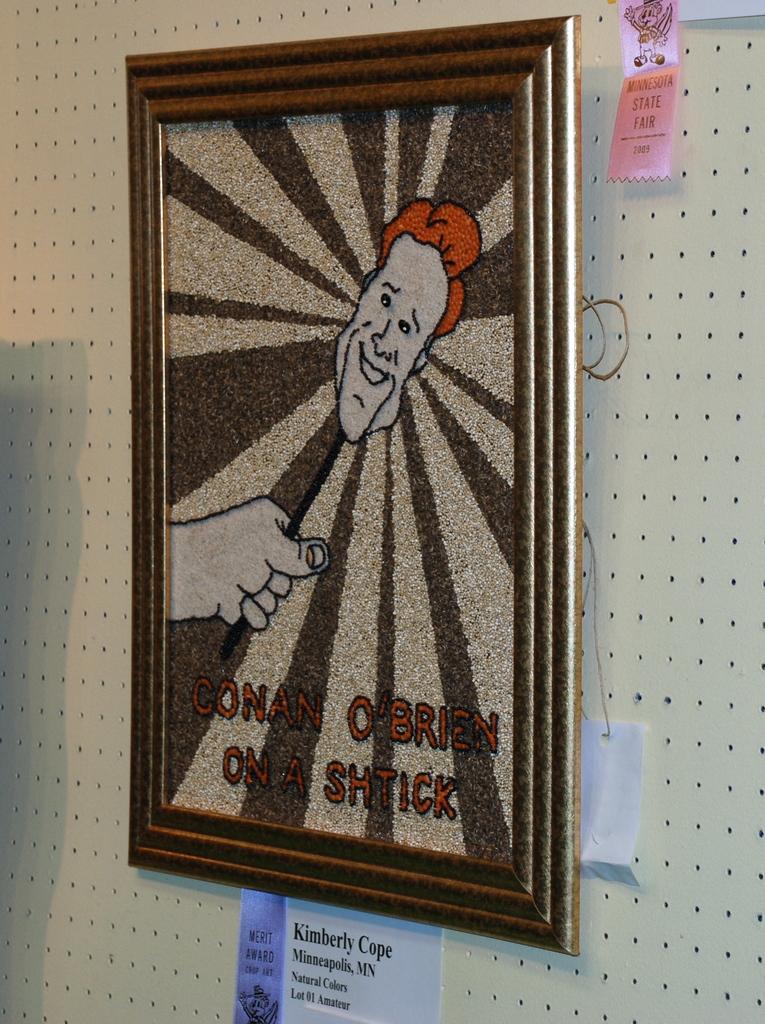Is that conan o brian?
Give a very brief answer. Yes. Which celebrity is on the poster?
Make the answer very short. Conan o'brien. 